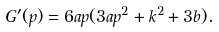Convert formula to latex. <formula><loc_0><loc_0><loc_500><loc_500>G ^ { \prime } ( p ) = 6 a p ( 3 a p ^ { 2 } + k ^ { 2 } + 3 b ) .</formula> 